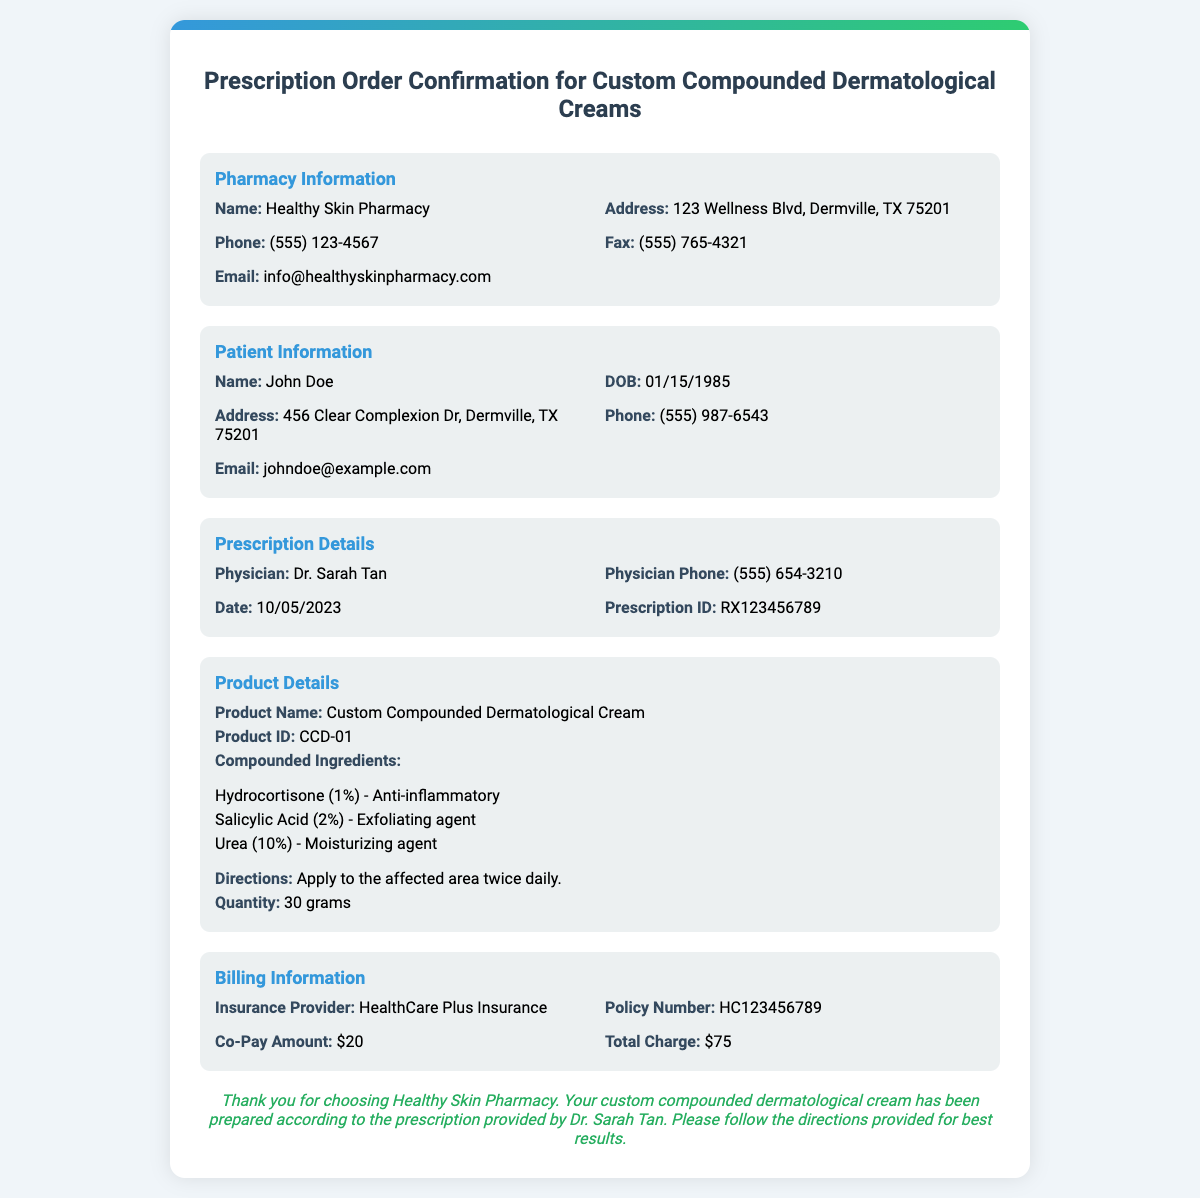What is the name of the pharmacy? The pharmacy's name is provided in the document under Pharmacy Information.
Answer: Healthy Skin Pharmacy Who is the physician associated with the prescription? The document specifies the physician's name in the Prescription Details section.
Answer: Dr. Sarah Tan What is the quantity of the compounded cream? The quantity is listed under the Product Details section.
Answer: 30 grams What is the co-pay amount? The co-pay amount is detailed in the Billing Information section.
Answer: $20 What are the compounded ingredients in the cream? The ingredients are listed under the Product Details section, all of which must be included in the answer.
Answer: Hydrocortisone (1%), Salicylic Acid (2%), Urea (10%) What is the total charge for the prescription? The total charge can be found in the Billing Information section of the document.
Answer: $75 When was the prescription issued? The issuance date of the prescription is specified in the Prescription Details section.
Answer: 10/05/2023 What directions are provided for using the cream? The directions for use are outlined in the Product Details section.
Answer: Apply to the affected area twice daily What is the insurance provider listed? The insurance provider's name is found under the Billing Information section.
Answer: HealthCare Plus Insurance 